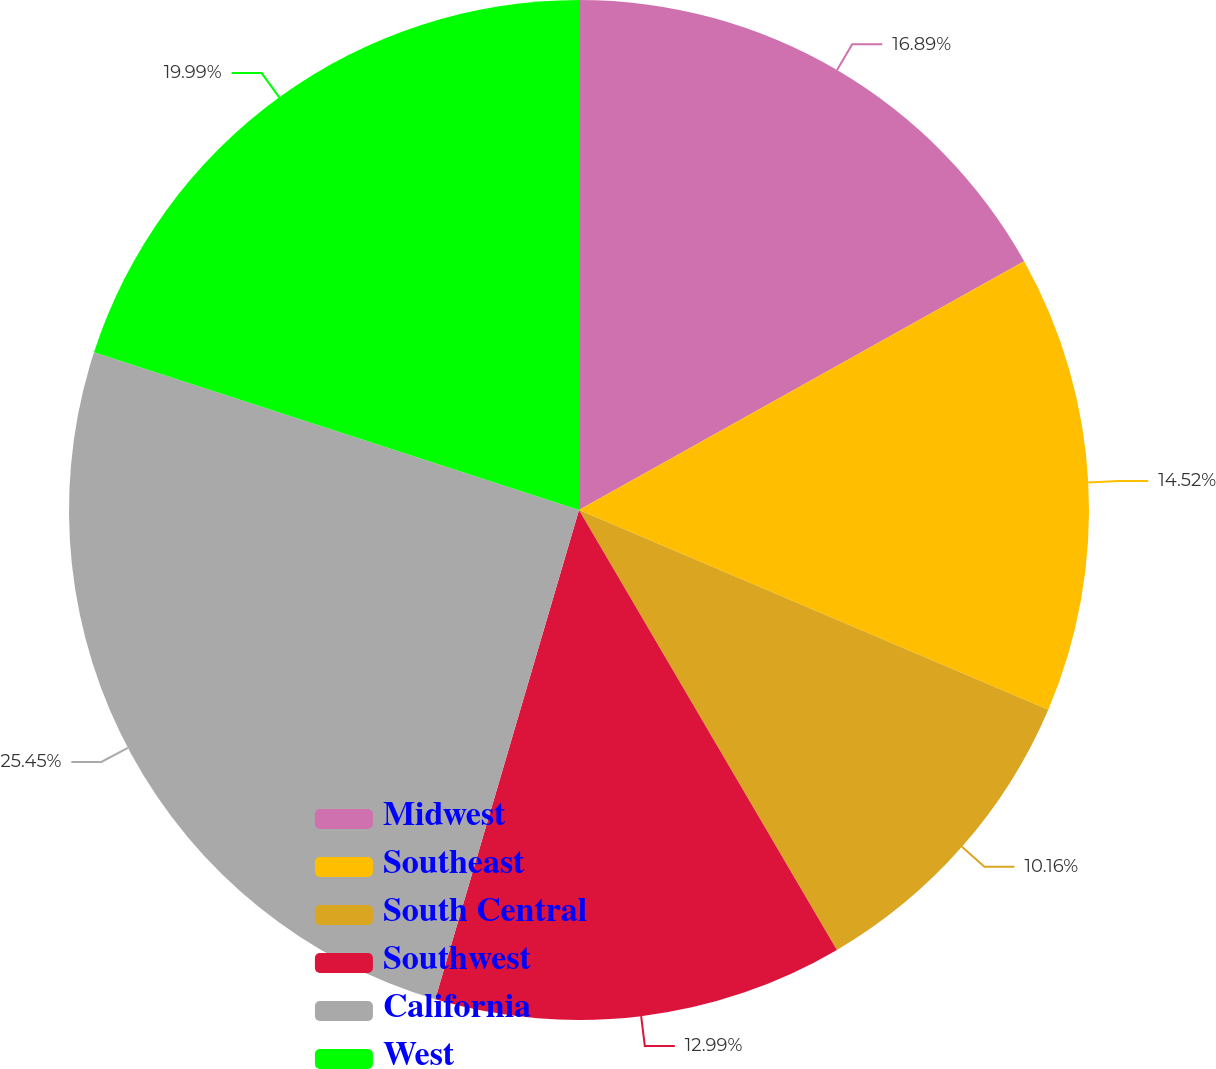Convert chart. <chart><loc_0><loc_0><loc_500><loc_500><pie_chart><fcel>Midwest<fcel>Southeast<fcel>South Central<fcel>Southwest<fcel>California<fcel>West<nl><fcel>16.89%<fcel>14.52%<fcel>10.16%<fcel>12.99%<fcel>25.46%<fcel>20.0%<nl></chart> 